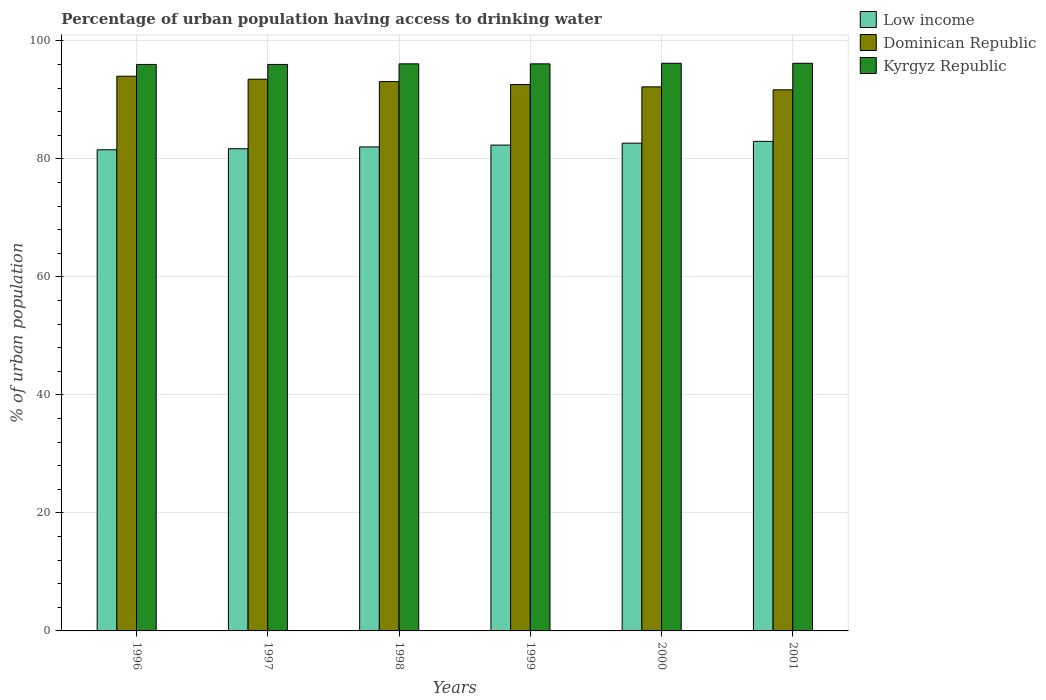How many different coloured bars are there?
Give a very brief answer. 3. Are the number of bars on each tick of the X-axis equal?
Make the answer very short. Yes. In how many cases, is the number of bars for a given year not equal to the number of legend labels?
Make the answer very short. 0. What is the percentage of urban population having access to drinking water in Dominican Republic in 1997?
Ensure brevity in your answer.  93.5. Across all years, what is the maximum percentage of urban population having access to drinking water in Dominican Republic?
Keep it short and to the point. 94. Across all years, what is the minimum percentage of urban population having access to drinking water in Dominican Republic?
Keep it short and to the point. 91.7. In which year was the percentage of urban population having access to drinking water in Dominican Republic minimum?
Offer a terse response. 2001. What is the total percentage of urban population having access to drinking water in Dominican Republic in the graph?
Keep it short and to the point. 557.1. What is the difference between the percentage of urban population having access to drinking water in Dominican Republic in 1996 and that in 2000?
Your answer should be very brief. 1.8. What is the difference between the percentage of urban population having access to drinking water in Dominican Republic in 2000 and the percentage of urban population having access to drinking water in Kyrgyz Republic in 1998?
Provide a short and direct response. -3.9. What is the average percentage of urban population having access to drinking water in Kyrgyz Republic per year?
Keep it short and to the point. 96.1. In the year 2001, what is the difference between the percentage of urban population having access to drinking water in Kyrgyz Republic and percentage of urban population having access to drinking water in Low income?
Make the answer very short. 13.24. In how many years, is the percentage of urban population having access to drinking water in Dominican Republic greater than 60 %?
Provide a succinct answer. 6. What is the ratio of the percentage of urban population having access to drinking water in Dominican Republic in 1997 to that in 1999?
Ensure brevity in your answer.  1.01. Is the percentage of urban population having access to drinking water in Kyrgyz Republic in 1996 less than that in 2001?
Provide a succinct answer. Yes. What is the difference between the highest and the lowest percentage of urban population having access to drinking water in Dominican Republic?
Give a very brief answer. 2.3. In how many years, is the percentage of urban population having access to drinking water in Kyrgyz Republic greater than the average percentage of urban population having access to drinking water in Kyrgyz Republic taken over all years?
Your answer should be very brief. 2. What does the 2nd bar from the left in 1998 represents?
Offer a terse response. Dominican Republic. What does the 1st bar from the right in 1998 represents?
Offer a very short reply. Kyrgyz Republic. Is it the case that in every year, the sum of the percentage of urban population having access to drinking water in Kyrgyz Republic and percentage of urban population having access to drinking water in Dominican Republic is greater than the percentage of urban population having access to drinking water in Low income?
Your response must be concise. Yes. Are all the bars in the graph horizontal?
Make the answer very short. No. What is the title of the graph?
Make the answer very short. Percentage of urban population having access to drinking water. Does "Liechtenstein" appear as one of the legend labels in the graph?
Provide a succinct answer. No. What is the label or title of the X-axis?
Give a very brief answer. Years. What is the label or title of the Y-axis?
Give a very brief answer. % of urban population. What is the % of urban population in Low income in 1996?
Your answer should be compact. 81.54. What is the % of urban population in Dominican Republic in 1996?
Your answer should be compact. 94. What is the % of urban population in Kyrgyz Republic in 1996?
Your response must be concise. 96. What is the % of urban population of Low income in 1997?
Make the answer very short. 81.72. What is the % of urban population of Dominican Republic in 1997?
Your answer should be very brief. 93.5. What is the % of urban population in Kyrgyz Republic in 1997?
Give a very brief answer. 96. What is the % of urban population of Low income in 1998?
Keep it short and to the point. 82.02. What is the % of urban population in Dominican Republic in 1998?
Offer a terse response. 93.1. What is the % of urban population of Kyrgyz Republic in 1998?
Ensure brevity in your answer.  96.1. What is the % of urban population in Low income in 1999?
Offer a terse response. 82.33. What is the % of urban population of Dominican Republic in 1999?
Your response must be concise. 92.6. What is the % of urban population of Kyrgyz Republic in 1999?
Give a very brief answer. 96.1. What is the % of urban population in Low income in 2000?
Offer a terse response. 82.66. What is the % of urban population in Dominican Republic in 2000?
Your answer should be compact. 92.2. What is the % of urban population of Kyrgyz Republic in 2000?
Offer a very short reply. 96.2. What is the % of urban population of Low income in 2001?
Your answer should be very brief. 82.96. What is the % of urban population in Dominican Republic in 2001?
Offer a very short reply. 91.7. What is the % of urban population in Kyrgyz Republic in 2001?
Your answer should be compact. 96.2. Across all years, what is the maximum % of urban population of Low income?
Offer a very short reply. 82.96. Across all years, what is the maximum % of urban population of Dominican Republic?
Give a very brief answer. 94. Across all years, what is the maximum % of urban population of Kyrgyz Republic?
Your response must be concise. 96.2. Across all years, what is the minimum % of urban population in Low income?
Your answer should be compact. 81.54. Across all years, what is the minimum % of urban population in Dominican Republic?
Provide a succinct answer. 91.7. Across all years, what is the minimum % of urban population in Kyrgyz Republic?
Make the answer very short. 96. What is the total % of urban population in Low income in the graph?
Your answer should be compact. 493.23. What is the total % of urban population of Dominican Republic in the graph?
Your response must be concise. 557.1. What is the total % of urban population of Kyrgyz Republic in the graph?
Your answer should be compact. 576.6. What is the difference between the % of urban population in Low income in 1996 and that in 1997?
Keep it short and to the point. -0.18. What is the difference between the % of urban population in Dominican Republic in 1996 and that in 1997?
Keep it short and to the point. 0.5. What is the difference between the % of urban population of Low income in 1996 and that in 1998?
Your response must be concise. -0.48. What is the difference between the % of urban population in Kyrgyz Republic in 1996 and that in 1998?
Offer a very short reply. -0.1. What is the difference between the % of urban population of Low income in 1996 and that in 1999?
Offer a terse response. -0.79. What is the difference between the % of urban population of Kyrgyz Republic in 1996 and that in 1999?
Provide a succinct answer. -0.1. What is the difference between the % of urban population of Low income in 1996 and that in 2000?
Your answer should be very brief. -1.12. What is the difference between the % of urban population of Low income in 1996 and that in 2001?
Give a very brief answer. -1.42. What is the difference between the % of urban population in Dominican Republic in 1996 and that in 2001?
Make the answer very short. 2.3. What is the difference between the % of urban population of Kyrgyz Republic in 1996 and that in 2001?
Your answer should be compact. -0.2. What is the difference between the % of urban population in Low income in 1997 and that in 1998?
Provide a short and direct response. -0.31. What is the difference between the % of urban population of Low income in 1997 and that in 1999?
Your answer should be compact. -0.62. What is the difference between the % of urban population in Dominican Republic in 1997 and that in 1999?
Offer a very short reply. 0.9. What is the difference between the % of urban population of Kyrgyz Republic in 1997 and that in 1999?
Provide a succinct answer. -0.1. What is the difference between the % of urban population in Low income in 1997 and that in 2000?
Provide a succinct answer. -0.94. What is the difference between the % of urban population of Dominican Republic in 1997 and that in 2000?
Keep it short and to the point. 1.3. What is the difference between the % of urban population of Kyrgyz Republic in 1997 and that in 2000?
Offer a very short reply. -0.2. What is the difference between the % of urban population in Low income in 1997 and that in 2001?
Your response must be concise. -1.25. What is the difference between the % of urban population in Low income in 1998 and that in 1999?
Provide a short and direct response. -0.31. What is the difference between the % of urban population in Kyrgyz Republic in 1998 and that in 1999?
Your response must be concise. 0. What is the difference between the % of urban population in Low income in 1998 and that in 2000?
Your answer should be compact. -0.64. What is the difference between the % of urban population of Kyrgyz Republic in 1998 and that in 2000?
Provide a short and direct response. -0.1. What is the difference between the % of urban population in Low income in 1998 and that in 2001?
Provide a succinct answer. -0.94. What is the difference between the % of urban population of Low income in 1999 and that in 2000?
Ensure brevity in your answer.  -0.32. What is the difference between the % of urban population in Dominican Republic in 1999 and that in 2000?
Offer a terse response. 0.4. What is the difference between the % of urban population in Low income in 1999 and that in 2001?
Your answer should be compact. -0.63. What is the difference between the % of urban population of Dominican Republic in 1999 and that in 2001?
Your answer should be very brief. 0.9. What is the difference between the % of urban population in Kyrgyz Republic in 1999 and that in 2001?
Offer a very short reply. -0.1. What is the difference between the % of urban population in Low income in 2000 and that in 2001?
Your response must be concise. -0.31. What is the difference between the % of urban population in Dominican Republic in 2000 and that in 2001?
Give a very brief answer. 0.5. What is the difference between the % of urban population in Kyrgyz Republic in 2000 and that in 2001?
Your answer should be very brief. 0. What is the difference between the % of urban population in Low income in 1996 and the % of urban population in Dominican Republic in 1997?
Your response must be concise. -11.96. What is the difference between the % of urban population of Low income in 1996 and the % of urban population of Kyrgyz Republic in 1997?
Your answer should be compact. -14.46. What is the difference between the % of urban population in Low income in 1996 and the % of urban population in Dominican Republic in 1998?
Give a very brief answer. -11.56. What is the difference between the % of urban population in Low income in 1996 and the % of urban population in Kyrgyz Republic in 1998?
Give a very brief answer. -14.56. What is the difference between the % of urban population in Low income in 1996 and the % of urban population in Dominican Republic in 1999?
Give a very brief answer. -11.06. What is the difference between the % of urban population of Low income in 1996 and the % of urban population of Kyrgyz Republic in 1999?
Your response must be concise. -14.56. What is the difference between the % of urban population of Dominican Republic in 1996 and the % of urban population of Kyrgyz Republic in 1999?
Offer a terse response. -2.1. What is the difference between the % of urban population of Low income in 1996 and the % of urban population of Dominican Republic in 2000?
Ensure brevity in your answer.  -10.66. What is the difference between the % of urban population in Low income in 1996 and the % of urban population in Kyrgyz Republic in 2000?
Provide a short and direct response. -14.66. What is the difference between the % of urban population of Dominican Republic in 1996 and the % of urban population of Kyrgyz Republic in 2000?
Offer a terse response. -2.2. What is the difference between the % of urban population of Low income in 1996 and the % of urban population of Dominican Republic in 2001?
Your answer should be very brief. -10.16. What is the difference between the % of urban population in Low income in 1996 and the % of urban population in Kyrgyz Republic in 2001?
Ensure brevity in your answer.  -14.66. What is the difference between the % of urban population of Low income in 1997 and the % of urban population of Dominican Republic in 1998?
Provide a succinct answer. -11.38. What is the difference between the % of urban population of Low income in 1997 and the % of urban population of Kyrgyz Republic in 1998?
Provide a succinct answer. -14.38. What is the difference between the % of urban population in Low income in 1997 and the % of urban population in Dominican Republic in 1999?
Make the answer very short. -10.88. What is the difference between the % of urban population in Low income in 1997 and the % of urban population in Kyrgyz Republic in 1999?
Ensure brevity in your answer.  -14.38. What is the difference between the % of urban population of Dominican Republic in 1997 and the % of urban population of Kyrgyz Republic in 1999?
Keep it short and to the point. -2.6. What is the difference between the % of urban population in Low income in 1997 and the % of urban population in Dominican Republic in 2000?
Keep it short and to the point. -10.48. What is the difference between the % of urban population of Low income in 1997 and the % of urban population of Kyrgyz Republic in 2000?
Your answer should be very brief. -14.48. What is the difference between the % of urban population of Dominican Republic in 1997 and the % of urban population of Kyrgyz Republic in 2000?
Keep it short and to the point. -2.7. What is the difference between the % of urban population in Low income in 1997 and the % of urban population in Dominican Republic in 2001?
Give a very brief answer. -9.98. What is the difference between the % of urban population in Low income in 1997 and the % of urban population in Kyrgyz Republic in 2001?
Make the answer very short. -14.48. What is the difference between the % of urban population in Dominican Republic in 1997 and the % of urban population in Kyrgyz Republic in 2001?
Provide a succinct answer. -2.7. What is the difference between the % of urban population of Low income in 1998 and the % of urban population of Dominican Republic in 1999?
Offer a very short reply. -10.58. What is the difference between the % of urban population of Low income in 1998 and the % of urban population of Kyrgyz Republic in 1999?
Offer a terse response. -14.08. What is the difference between the % of urban population in Low income in 1998 and the % of urban population in Dominican Republic in 2000?
Make the answer very short. -10.18. What is the difference between the % of urban population of Low income in 1998 and the % of urban population of Kyrgyz Republic in 2000?
Give a very brief answer. -14.18. What is the difference between the % of urban population in Low income in 1998 and the % of urban population in Dominican Republic in 2001?
Offer a very short reply. -9.68. What is the difference between the % of urban population of Low income in 1998 and the % of urban population of Kyrgyz Republic in 2001?
Your response must be concise. -14.18. What is the difference between the % of urban population of Dominican Republic in 1998 and the % of urban population of Kyrgyz Republic in 2001?
Your response must be concise. -3.1. What is the difference between the % of urban population of Low income in 1999 and the % of urban population of Dominican Republic in 2000?
Provide a succinct answer. -9.87. What is the difference between the % of urban population of Low income in 1999 and the % of urban population of Kyrgyz Republic in 2000?
Your answer should be very brief. -13.87. What is the difference between the % of urban population in Low income in 1999 and the % of urban population in Dominican Republic in 2001?
Offer a very short reply. -9.37. What is the difference between the % of urban population of Low income in 1999 and the % of urban population of Kyrgyz Republic in 2001?
Give a very brief answer. -13.87. What is the difference between the % of urban population of Dominican Republic in 1999 and the % of urban population of Kyrgyz Republic in 2001?
Keep it short and to the point. -3.6. What is the difference between the % of urban population in Low income in 2000 and the % of urban population in Dominican Republic in 2001?
Offer a very short reply. -9.04. What is the difference between the % of urban population in Low income in 2000 and the % of urban population in Kyrgyz Republic in 2001?
Make the answer very short. -13.54. What is the difference between the % of urban population in Dominican Republic in 2000 and the % of urban population in Kyrgyz Republic in 2001?
Offer a terse response. -4. What is the average % of urban population in Low income per year?
Your answer should be very brief. 82.21. What is the average % of urban population in Dominican Republic per year?
Make the answer very short. 92.85. What is the average % of urban population of Kyrgyz Republic per year?
Make the answer very short. 96.1. In the year 1996, what is the difference between the % of urban population in Low income and % of urban population in Dominican Republic?
Offer a terse response. -12.46. In the year 1996, what is the difference between the % of urban population in Low income and % of urban population in Kyrgyz Republic?
Make the answer very short. -14.46. In the year 1996, what is the difference between the % of urban population in Dominican Republic and % of urban population in Kyrgyz Republic?
Make the answer very short. -2. In the year 1997, what is the difference between the % of urban population of Low income and % of urban population of Dominican Republic?
Provide a short and direct response. -11.78. In the year 1997, what is the difference between the % of urban population in Low income and % of urban population in Kyrgyz Republic?
Offer a terse response. -14.28. In the year 1998, what is the difference between the % of urban population of Low income and % of urban population of Dominican Republic?
Provide a short and direct response. -11.08. In the year 1998, what is the difference between the % of urban population of Low income and % of urban population of Kyrgyz Republic?
Offer a terse response. -14.08. In the year 1998, what is the difference between the % of urban population of Dominican Republic and % of urban population of Kyrgyz Republic?
Ensure brevity in your answer.  -3. In the year 1999, what is the difference between the % of urban population in Low income and % of urban population in Dominican Republic?
Give a very brief answer. -10.27. In the year 1999, what is the difference between the % of urban population in Low income and % of urban population in Kyrgyz Republic?
Offer a terse response. -13.77. In the year 1999, what is the difference between the % of urban population of Dominican Republic and % of urban population of Kyrgyz Republic?
Ensure brevity in your answer.  -3.5. In the year 2000, what is the difference between the % of urban population of Low income and % of urban population of Dominican Republic?
Offer a terse response. -9.54. In the year 2000, what is the difference between the % of urban population in Low income and % of urban population in Kyrgyz Republic?
Your answer should be very brief. -13.54. In the year 2000, what is the difference between the % of urban population in Dominican Republic and % of urban population in Kyrgyz Republic?
Provide a short and direct response. -4. In the year 2001, what is the difference between the % of urban population of Low income and % of urban population of Dominican Republic?
Offer a very short reply. -8.74. In the year 2001, what is the difference between the % of urban population of Low income and % of urban population of Kyrgyz Republic?
Your answer should be compact. -13.24. In the year 2001, what is the difference between the % of urban population of Dominican Republic and % of urban population of Kyrgyz Republic?
Provide a short and direct response. -4.5. What is the ratio of the % of urban population of Dominican Republic in 1996 to that in 1997?
Offer a very short reply. 1.01. What is the ratio of the % of urban population of Kyrgyz Republic in 1996 to that in 1997?
Make the answer very short. 1. What is the ratio of the % of urban population in Low income in 1996 to that in 1998?
Your answer should be very brief. 0.99. What is the ratio of the % of urban population in Dominican Republic in 1996 to that in 1998?
Provide a short and direct response. 1.01. What is the ratio of the % of urban population in Low income in 1996 to that in 1999?
Offer a very short reply. 0.99. What is the ratio of the % of urban population of Dominican Republic in 1996 to that in 1999?
Ensure brevity in your answer.  1.02. What is the ratio of the % of urban population in Kyrgyz Republic in 1996 to that in 1999?
Your response must be concise. 1. What is the ratio of the % of urban population in Low income in 1996 to that in 2000?
Your response must be concise. 0.99. What is the ratio of the % of urban population in Dominican Republic in 1996 to that in 2000?
Your answer should be very brief. 1.02. What is the ratio of the % of urban population in Kyrgyz Republic in 1996 to that in 2000?
Provide a succinct answer. 1. What is the ratio of the % of urban population of Low income in 1996 to that in 2001?
Make the answer very short. 0.98. What is the ratio of the % of urban population of Dominican Republic in 1996 to that in 2001?
Offer a terse response. 1.03. What is the ratio of the % of urban population of Kyrgyz Republic in 1996 to that in 2001?
Give a very brief answer. 1. What is the ratio of the % of urban population in Low income in 1997 to that in 1999?
Offer a very short reply. 0.99. What is the ratio of the % of urban population of Dominican Republic in 1997 to that in 1999?
Make the answer very short. 1.01. What is the ratio of the % of urban population of Kyrgyz Republic in 1997 to that in 1999?
Provide a short and direct response. 1. What is the ratio of the % of urban population of Dominican Republic in 1997 to that in 2000?
Ensure brevity in your answer.  1.01. What is the ratio of the % of urban population of Kyrgyz Republic in 1997 to that in 2000?
Keep it short and to the point. 1. What is the ratio of the % of urban population of Low income in 1997 to that in 2001?
Your response must be concise. 0.98. What is the ratio of the % of urban population of Dominican Republic in 1997 to that in 2001?
Your response must be concise. 1.02. What is the ratio of the % of urban population in Kyrgyz Republic in 1997 to that in 2001?
Ensure brevity in your answer.  1. What is the ratio of the % of urban population in Low income in 1998 to that in 1999?
Keep it short and to the point. 1. What is the ratio of the % of urban population in Dominican Republic in 1998 to that in 1999?
Ensure brevity in your answer.  1.01. What is the ratio of the % of urban population of Kyrgyz Republic in 1998 to that in 1999?
Provide a succinct answer. 1. What is the ratio of the % of urban population of Low income in 1998 to that in 2000?
Give a very brief answer. 0.99. What is the ratio of the % of urban population in Dominican Republic in 1998 to that in 2000?
Your response must be concise. 1.01. What is the ratio of the % of urban population of Kyrgyz Republic in 1998 to that in 2000?
Keep it short and to the point. 1. What is the ratio of the % of urban population of Low income in 1998 to that in 2001?
Keep it short and to the point. 0.99. What is the ratio of the % of urban population in Dominican Republic in 1998 to that in 2001?
Give a very brief answer. 1.02. What is the ratio of the % of urban population of Dominican Republic in 1999 to that in 2000?
Your answer should be compact. 1. What is the ratio of the % of urban population in Low income in 1999 to that in 2001?
Provide a succinct answer. 0.99. What is the ratio of the % of urban population in Dominican Republic in 1999 to that in 2001?
Provide a short and direct response. 1.01. What is the ratio of the % of urban population of Kyrgyz Republic in 1999 to that in 2001?
Your answer should be compact. 1. What is the ratio of the % of urban population in Low income in 2000 to that in 2001?
Provide a short and direct response. 1. What is the ratio of the % of urban population of Kyrgyz Republic in 2000 to that in 2001?
Provide a short and direct response. 1. What is the difference between the highest and the second highest % of urban population in Low income?
Ensure brevity in your answer.  0.31. What is the difference between the highest and the second highest % of urban population of Kyrgyz Republic?
Provide a succinct answer. 0. What is the difference between the highest and the lowest % of urban population in Low income?
Your response must be concise. 1.42. What is the difference between the highest and the lowest % of urban population of Kyrgyz Republic?
Your answer should be very brief. 0.2. 